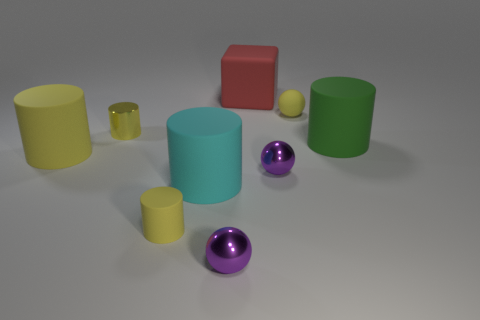Subtract all purple cubes. How many yellow cylinders are left? 3 Subtract 1 cylinders. How many cylinders are left? 4 Subtract all small matte cylinders. How many cylinders are left? 4 Subtract all purple cylinders. Subtract all red blocks. How many cylinders are left? 5 Add 1 tiny purple balls. How many objects exist? 10 Subtract all spheres. How many objects are left? 6 Subtract all cyan matte cylinders. Subtract all tiny yellow spheres. How many objects are left? 7 Add 2 shiny cylinders. How many shiny cylinders are left? 3 Add 4 small gray balls. How many small gray balls exist? 4 Subtract 0 red balls. How many objects are left? 9 